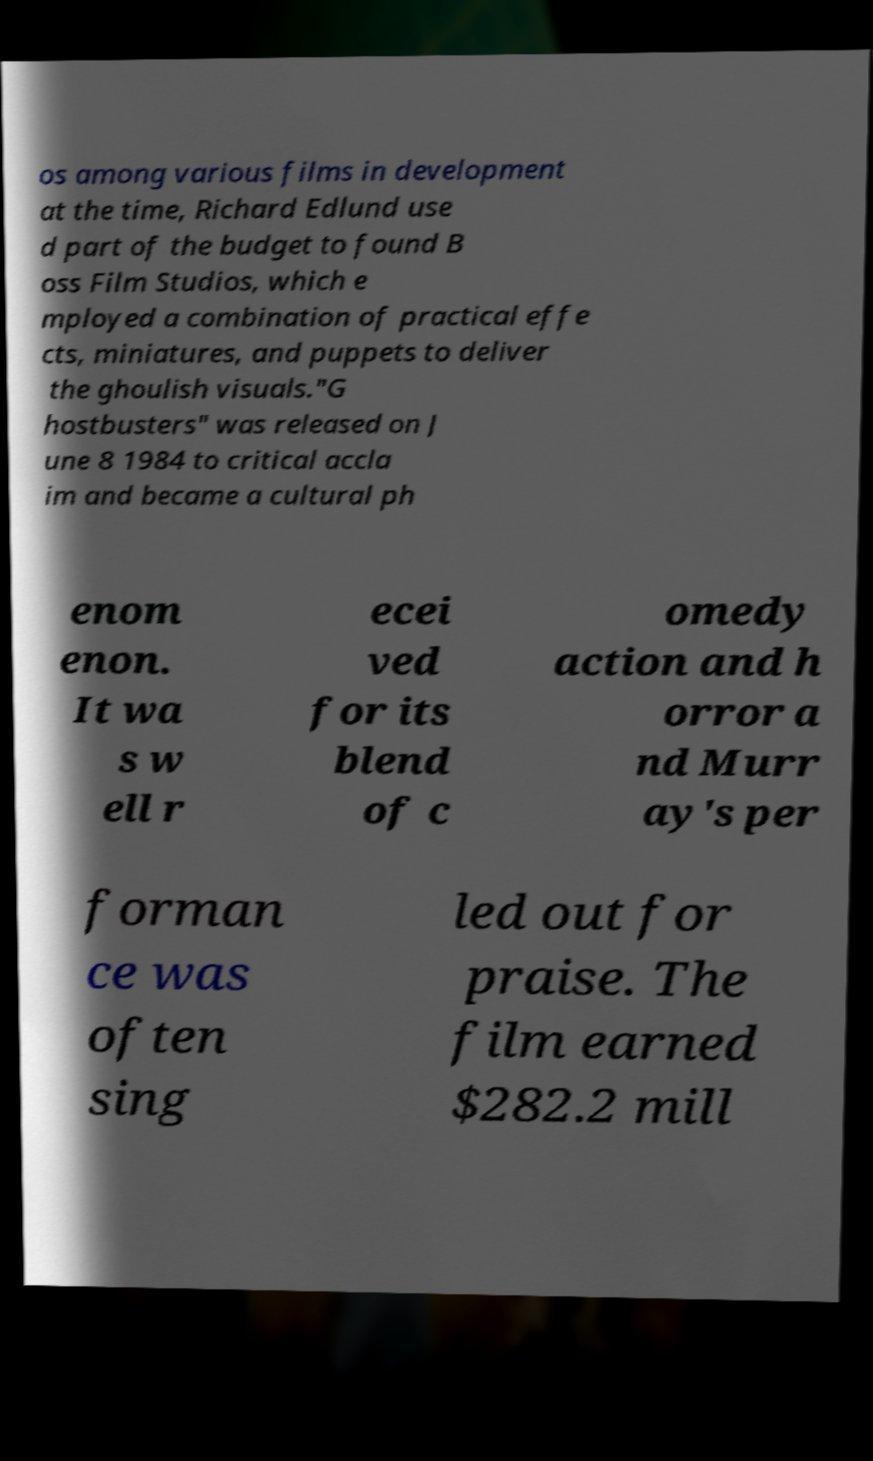Can you accurately transcribe the text from the provided image for me? os among various films in development at the time, Richard Edlund use d part of the budget to found B oss Film Studios, which e mployed a combination of practical effe cts, miniatures, and puppets to deliver the ghoulish visuals."G hostbusters" was released on J une 8 1984 to critical accla im and became a cultural ph enom enon. It wa s w ell r ecei ved for its blend of c omedy action and h orror a nd Murr ay's per forman ce was often sing led out for praise. The film earned $282.2 mill 